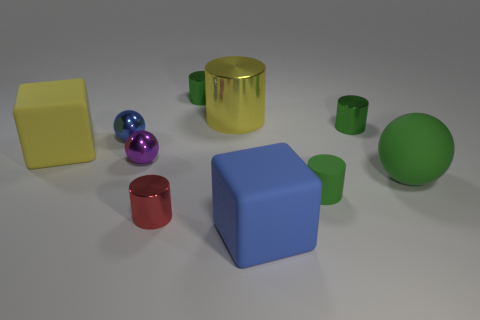Subtract all small metal spheres. How many spheres are left? 1 Subtract all yellow cylinders. How many cylinders are left? 4 Subtract 2 blocks. How many blocks are left? 0 Add 7 small blue balls. How many small blue balls exist? 8 Subtract 1 blue balls. How many objects are left? 9 Subtract all blocks. How many objects are left? 8 Subtract all cyan spheres. Subtract all blue cubes. How many spheres are left? 3 Subtract all purple cylinders. How many blue balls are left? 1 Subtract all big yellow metal cubes. Subtract all green spheres. How many objects are left? 9 Add 6 large green rubber balls. How many large green rubber balls are left? 7 